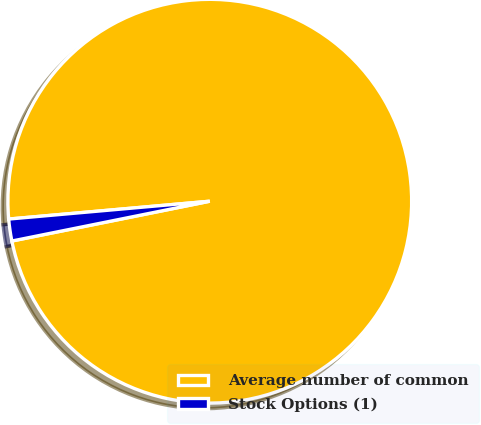Convert chart. <chart><loc_0><loc_0><loc_500><loc_500><pie_chart><fcel>Average number of common<fcel>Stock Options (1)<nl><fcel>98.25%<fcel>1.75%<nl></chart> 